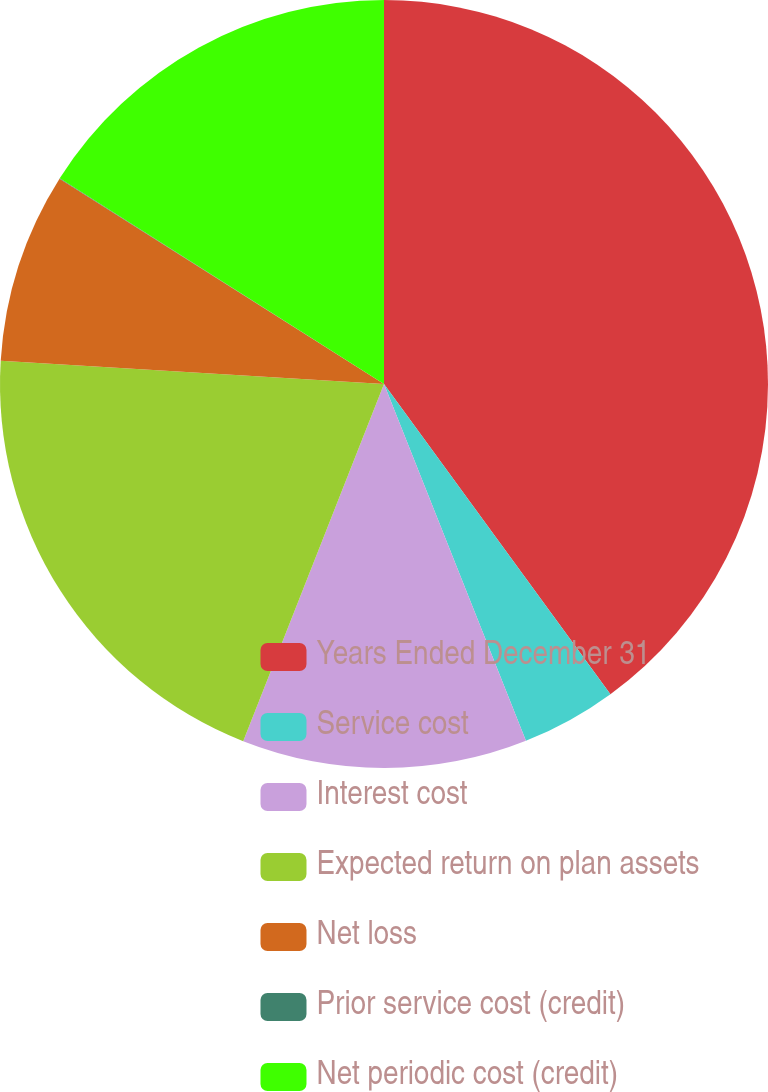Convert chart to OTSL. <chart><loc_0><loc_0><loc_500><loc_500><pie_chart><fcel>Years Ended December 31<fcel>Service cost<fcel>Interest cost<fcel>Expected return on plan assets<fcel>Net loss<fcel>Prior service cost (credit)<fcel>Net periodic cost (credit)<nl><fcel>39.96%<fcel>4.01%<fcel>12.0%<fcel>19.99%<fcel>8.01%<fcel>0.02%<fcel>16.0%<nl></chart> 